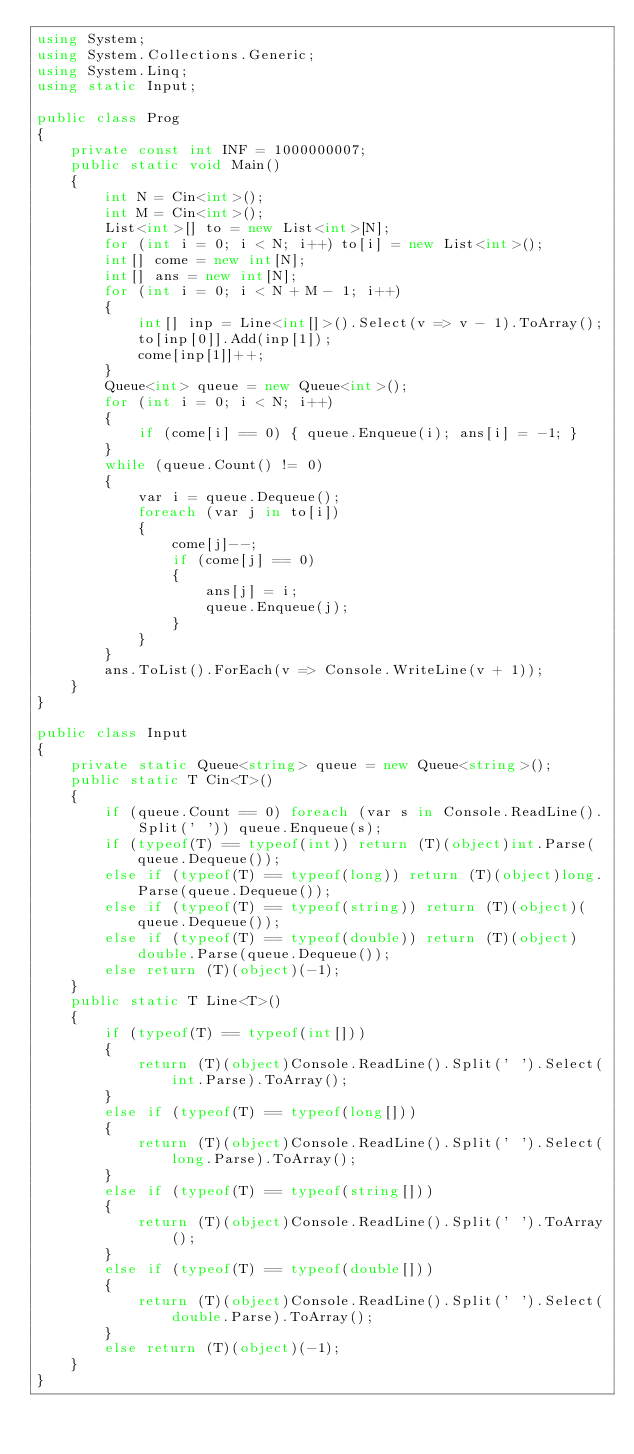Convert code to text. <code><loc_0><loc_0><loc_500><loc_500><_C#_>using System;
using System.Collections.Generic;
using System.Linq;
using static Input;

public class Prog
{
    private const int INF = 1000000007;
    public static void Main()
    {
        int N = Cin<int>();
        int M = Cin<int>();
        List<int>[] to = new List<int>[N];
        for (int i = 0; i < N; i++) to[i] = new List<int>();
        int[] come = new int[N];
        int[] ans = new int[N];
        for (int i = 0; i < N + M - 1; i++)
        {
            int[] inp = Line<int[]>().Select(v => v - 1).ToArray();
            to[inp[0]].Add(inp[1]);
            come[inp[1]]++;
        }
        Queue<int> queue = new Queue<int>();
        for (int i = 0; i < N; i++)
        {
            if (come[i] == 0) { queue.Enqueue(i); ans[i] = -1; }
        }
        while (queue.Count() != 0)
        {
            var i = queue.Dequeue();
            foreach (var j in to[i])
            {
                come[j]--;
                if (come[j] == 0)
                {
                    ans[j] = i;
                    queue.Enqueue(j);
                }
            }
        }
        ans.ToList().ForEach(v => Console.WriteLine(v + 1));
    }
}

public class Input
{
    private static Queue<string> queue = new Queue<string>();
    public static T Cin<T>()
    {
        if (queue.Count == 0) foreach (var s in Console.ReadLine().Split(' ')) queue.Enqueue(s);
        if (typeof(T) == typeof(int)) return (T)(object)int.Parse(queue.Dequeue());
        else if (typeof(T) == typeof(long)) return (T)(object)long.Parse(queue.Dequeue());
        else if (typeof(T) == typeof(string)) return (T)(object)(queue.Dequeue());
        else if (typeof(T) == typeof(double)) return (T)(object)double.Parse(queue.Dequeue());
        else return (T)(object)(-1);
    }
    public static T Line<T>()
    {
        if (typeof(T) == typeof(int[]))
        {
            return (T)(object)Console.ReadLine().Split(' ').Select(int.Parse).ToArray();
        }
        else if (typeof(T) == typeof(long[]))
        {
            return (T)(object)Console.ReadLine().Split(' ').Select(long.Parse).ToArray();
        }
        else if (typeof(T) == typeof(string[]))
        {
            return (T)(object)Console.ReadLine().Split(' ').ToArray();
        }
        else if (typeof(T) == typeof(double[]))
        {
            return (T)(object)Console.ReadLine().Split(' ').Select(double.Parse).ToArray();
        }
        else return (T)(object)(-1);
    }
}</code> 